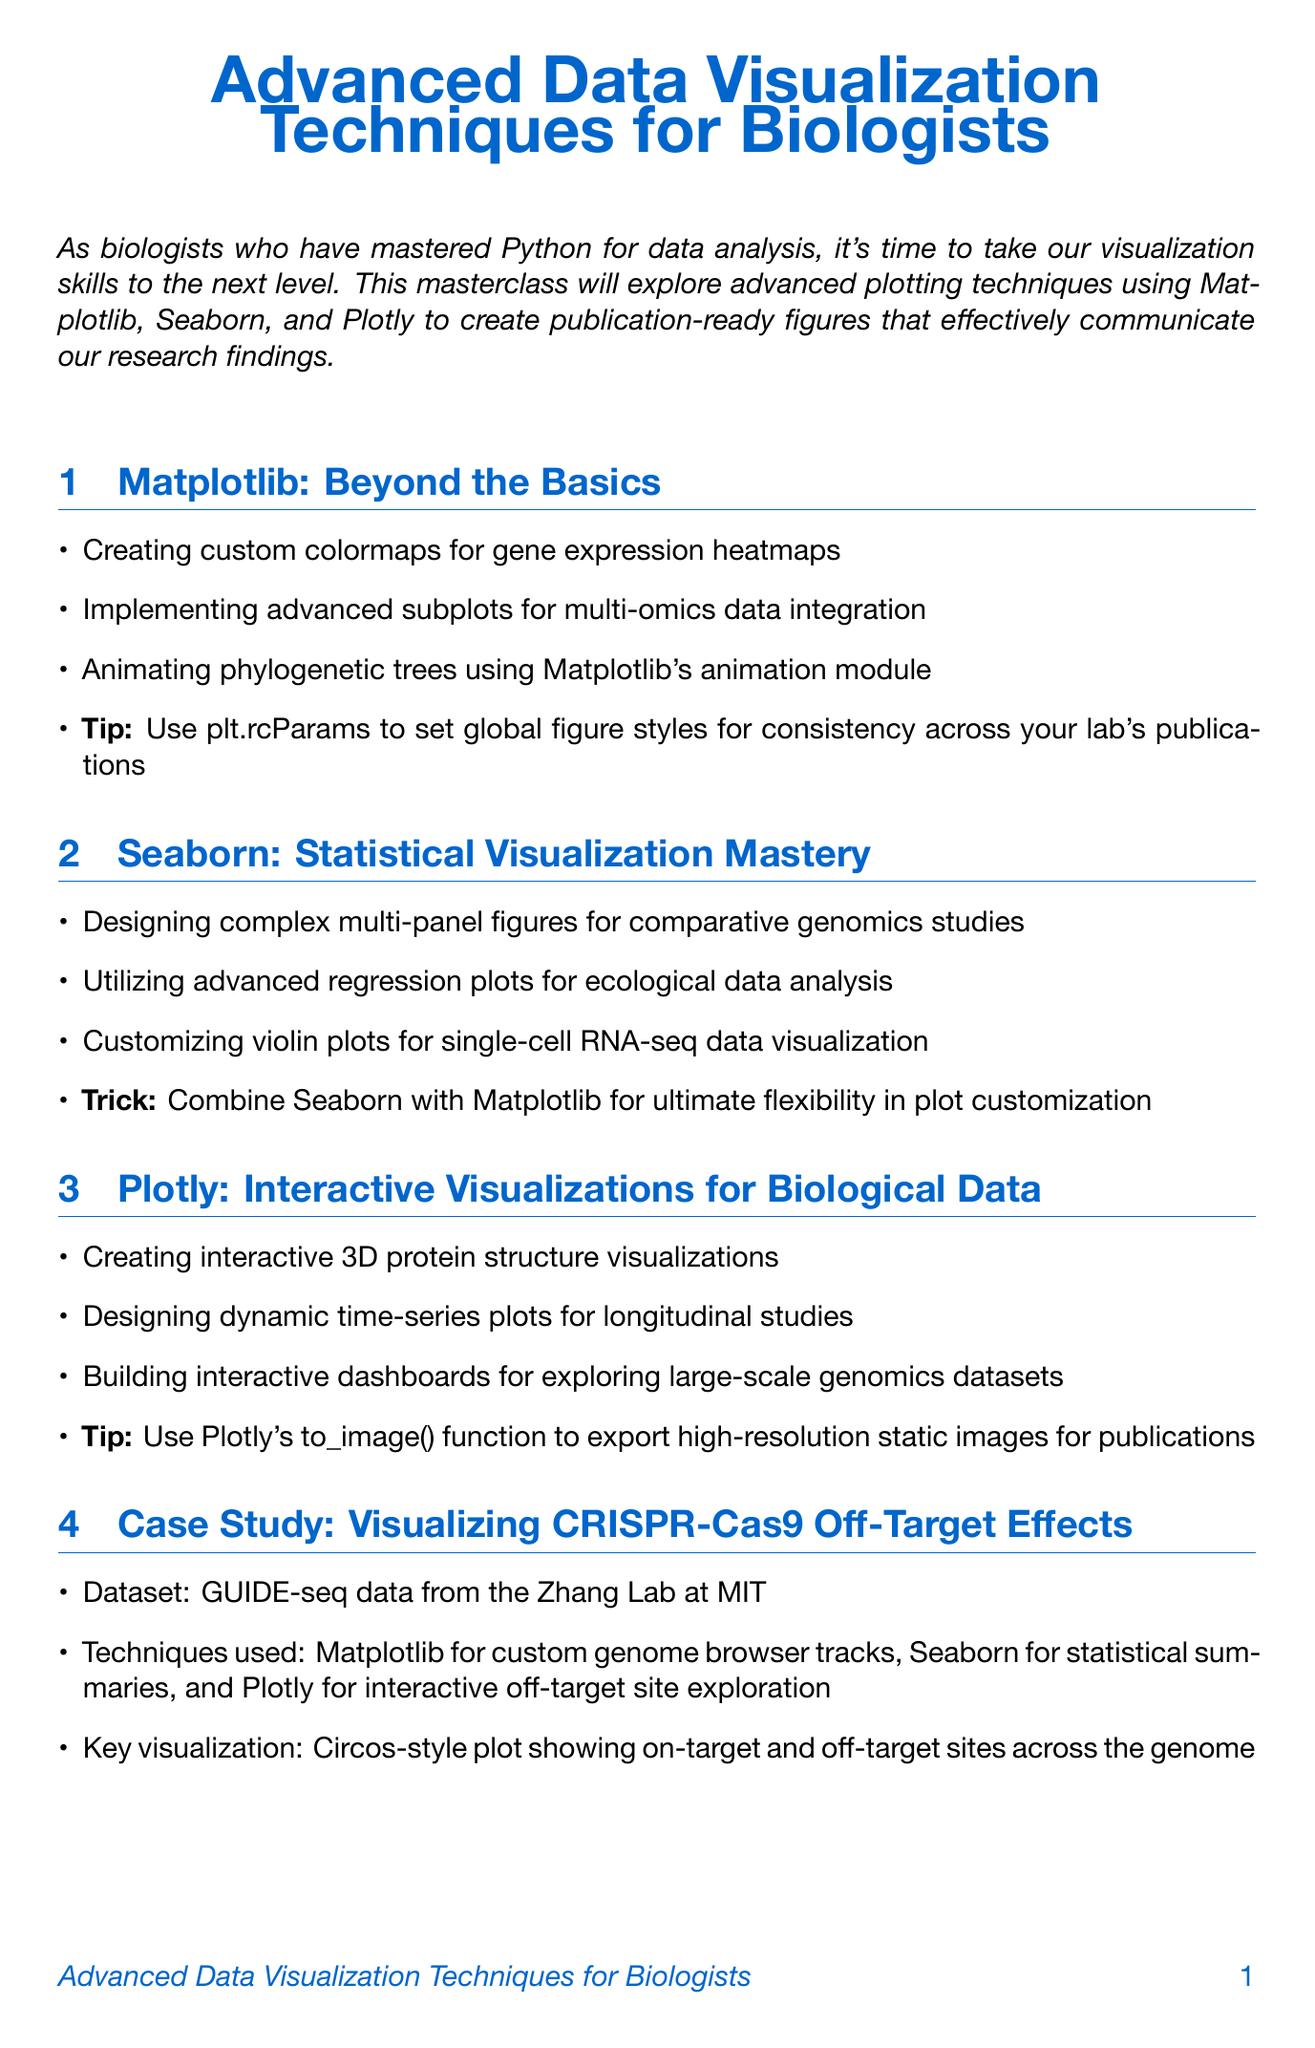What is the title of the newsletter? The title of the newsletter is stated at the beginning of the document.
Answer: Advanced Data Visualization Techniques for Biologists Which Python libraries are emphasized in the masterclass? The masterclass focuses on advanced plotting techniques using Matplotlib, Seaborn, and Plotly.
Answer: Matplotlib, Seaborn, Plotly What is a tip mentioned for Matplotlib? The document includes tips for using Matplotlib, specifically highlighting how to maintain consistency.
Answer: Use plt.rcParams to set global figure styles for consistency across your lab's publications What technique is used in the CRISPR-Cas9 case study? The case study describes the visualization techniques applied to off-target effects.
Answer: Matplotlib for custom genome browser tracks, Seaborn for statistical summaries, and Plotly for interactive off-target site exploration What is the recommended colormap family for color-blind friendly palettes? The document suggests a specific colormap for ensuring accessibility in figures.
Answer: viridis Who authored the interactive plasmid map generator? The community spotlight mentions an innovative visualization created by a specific researcher.
Answer: Dr. Sarah Johnson What is the purpose of the upcoming workshops section? This section provides information about resources available to enhance visualization skills.
Answer: To inform about workshops and resources What format should be used for final exports to maintain quality? The document suggests specific formats for exporting figures to ensure quality.
Answer: SVG, PDF Which online course is mentioned in the resources? The resources section lists available online courses for further learning.
Answer: Mastering Scientific Figures with Python on Coursera 